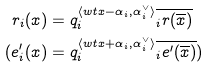<formula> <loc_0><loc_0><loc_500><loc_500>r _ { i } ( x ) & = q _ { i } ^ { \langle w t x - \alpha _ { i } , \alpha _ { i } ^ { \vee } \rangle } \overline { _ { i } r ( \overline { x } ) } \\ ( e ^ { \prime } _ { i } ( x ) & = q _ { i } ^ { \langle w t x + \alpha _ { i } , \alpha _ { i } ^ { \vee } \rangle } \overline { _ { i } { e ^ { \prime } } ( \overline { x } ) } )</formula> 